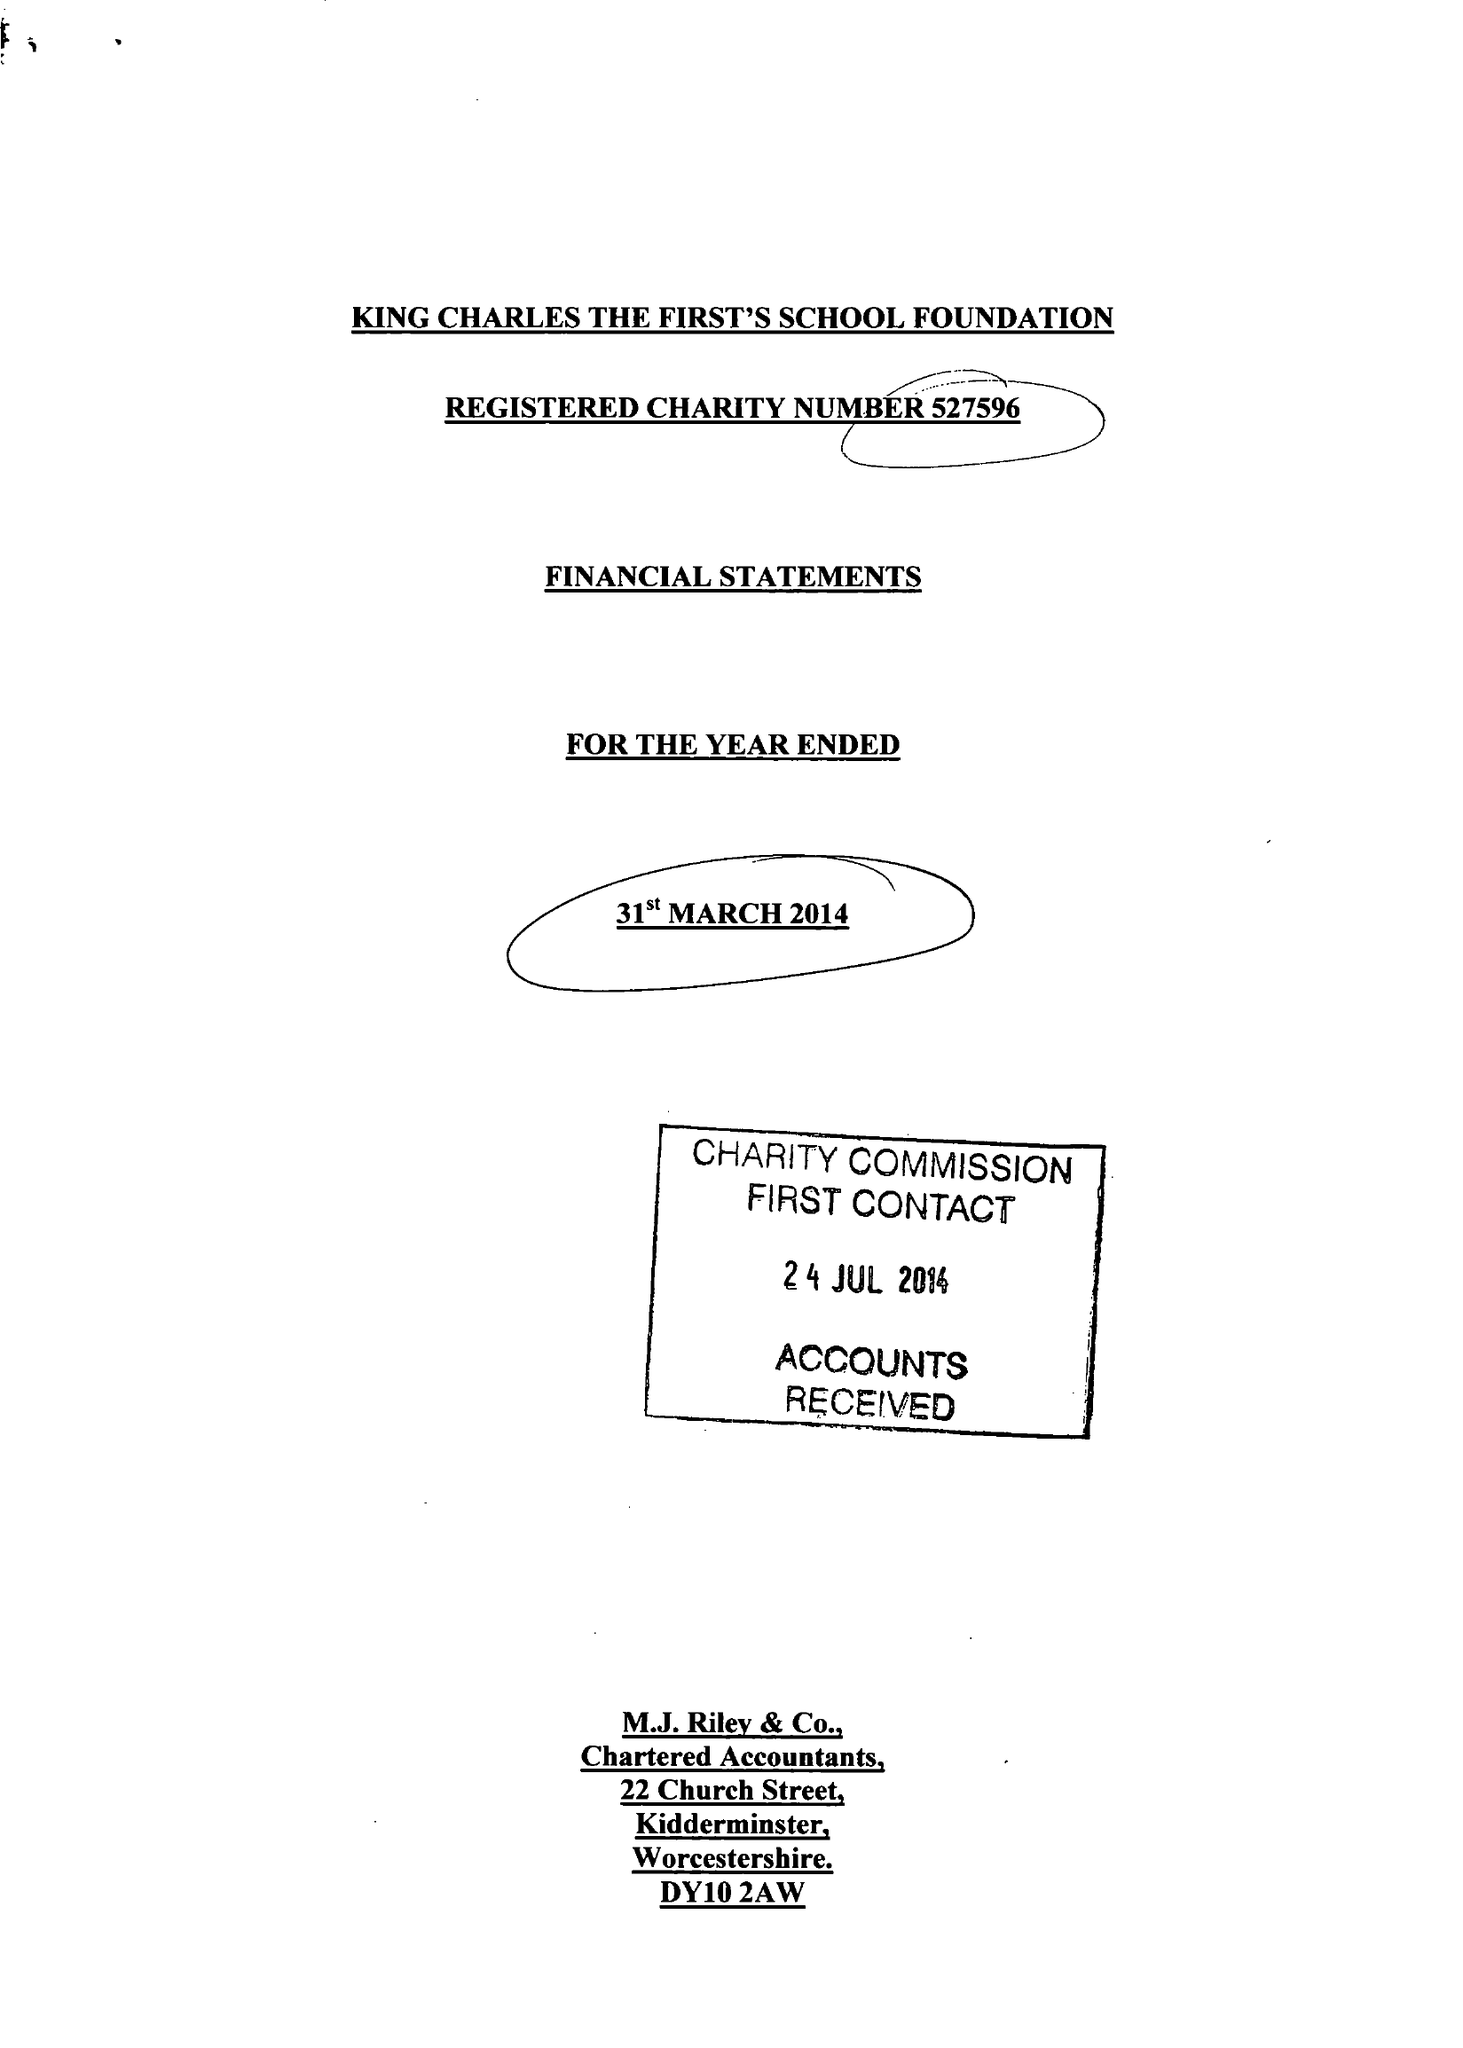What is the value for the charity_number?
Answer the question using a single word or phrase. 527596 